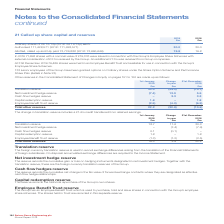According to Spirax Sarco Engineering Plc's financial document, What is the  Translation reserve at the beginning of 2019? According to the financial document, 30.3 (in millions). The relevant text states: "Translation reserve 30.3 (45.0) (14.7)..." Also, What does the change in translation reserve include? a £1.4m credit transferred from retained earnings. The document states: "The change in translation reserve includes a £1.4m credit transferred from retained earnings...." Also, What are the types of Other reserves? The document contains multiple relevant values: Translation reserve, Net investment hedge reserve, Cash flow hedges reserve, Capital redemption reserve, Employee Benefit Trust reserve. From the document: "Net investment hedge reserve (7.4) 12.9 5.5 Translation reserve 30.3 (45.0) (14.7) Cash flow hedges reserve – 3.3 3.3 Capital redemption reserve 1.8 –..." Additionally, How many types of other reserves registered a negative Change in year amount? According to the financial document, 2. The relevant text states: "Spirax-Sarco Engineering plc Annual Report 2019..." Also, can you calculate: What was the amount of capital redemption reserve as a percentage of the total other reserves on 1st January 2019? Based on the calculation: 1.8/22.2, the result is 8.11 (percentage). This is based on the information: "Capital redemption reserve 1.8 – 1.8 Total other reserves 22.2 (32.8) (10.6)..." The key data points involved are: 1.8, 22.2. Also, can you calculate: What was the percentage change in the amount of  Translation reserve  from 1st January 2019 to 31st December 2019? To answer this question, I need to perform calculations using the financial data. The calculation is: (-14.7-30.3)/30.3, which equals -148.51 (percentage). This is based on the information: "Translation reserve 30.3 (45.0) (14.7) Translation reserve 30.3 (45.0) (14.7)..." The key data points involved are: 14.7, 30.3. 